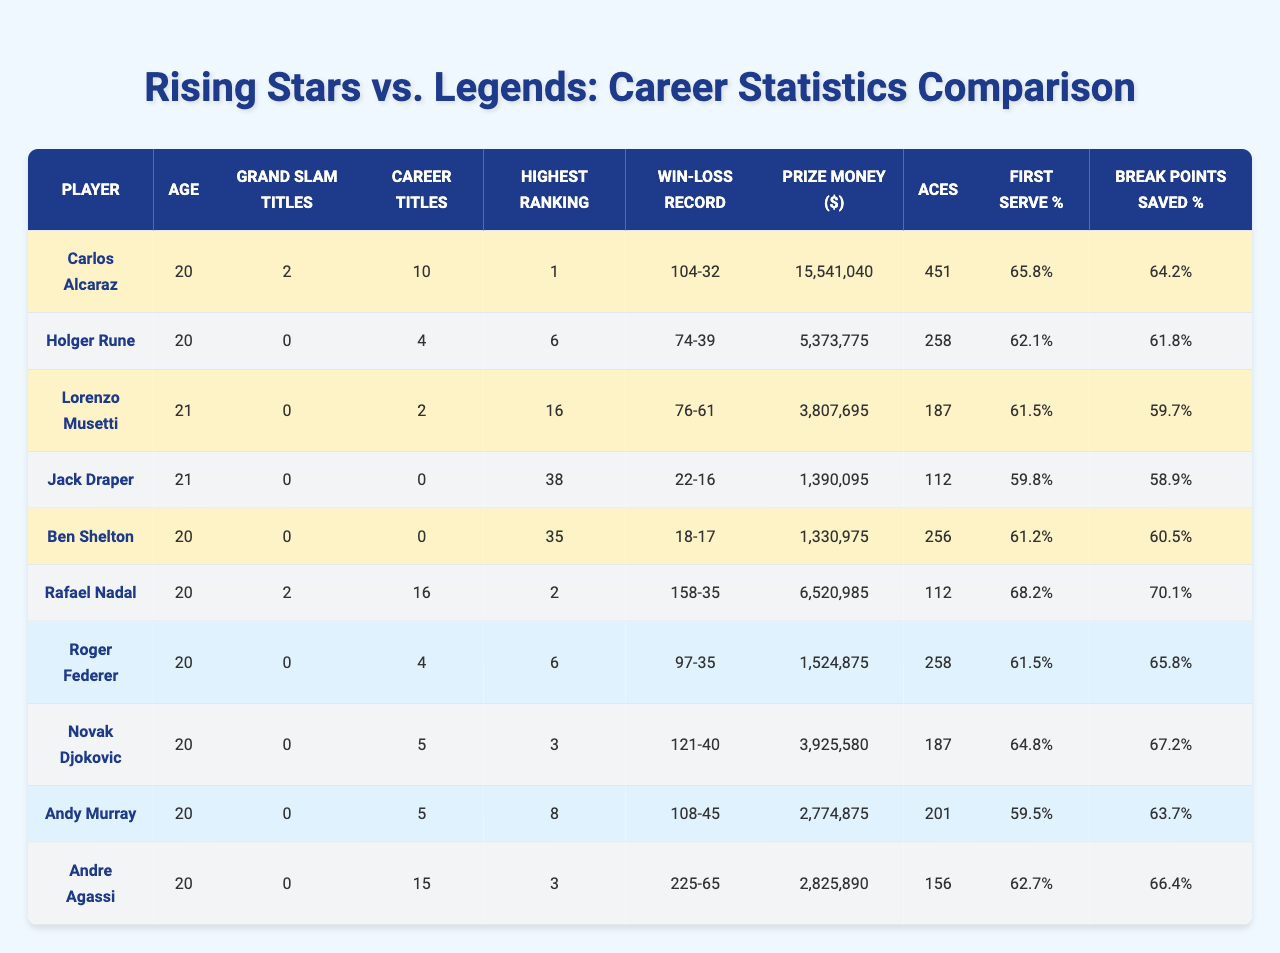What is the highest ranking achieved by Carlos Alcaraz? Referring to the table, Carlos Alcaraz has a highest ranking of 1.
Answer: 1 Who has the most career titles among the rising stars? By looking at the career titles of the rising stars, Carlos Alcaraz has 10, which is the highest among them.
Answer: 10 Does Jack Draper have any career titles? According to the table, Jack Draper has 0 career titles.
Answer: No What percentage of break points did Rafael Nadal save? The table shows that Rafael Nadal saved 70.1% of break points.
Answer: 70.1% Which player has the highest prize money among the legends? Scanning through the prize money values, Andre Agassi has the highest at $2,825,890.
Answer: $2,825,890 What is the average age of the rising stars listed in the table? The ages of the rising stars are 20, 20, 21, 21, and 20. Their total age is 102, and dividing by the 5 players gives an average age of 20.4.
Answer: 20.4 Is Holger Rune's win-loss record better than Andy Murray's? Holger Rune has a win-loss record of 74-39, which equates to a winning percentage of approximately 65.5%. Andy Murray has a record of 108-45, which results in about 70.7%. Thus, Andy's record is better.
Answer: No What is the total number of Grand Slam titles won by the legends listed? Adding up the Grand Slam titles: Rafael Nadal (2) + Roger Federer (0) + Novak Djokovic (0) + Andy Murray (0) + Andre Agassi (0) gives a total of 2.
Answer: 2 Which rising star has the lowest first serve percentage? Upon reviewing the first serve percentages, Jack Draper has the lowest at 59.8%.
Answer: 59.8% How many aces did the legends hit in total? Summing up their aces: Nadal (112) + Federer (258) + Djokovic (187) + Murray (201) + Agassi (156) gives a total of 914 aces.
Answer: 914 Who saved more break points, Lorenzo Musetti or Andre Agassi? Lorenzo Musetti saved 59.7% while Andre Agassi saved 66.4%. Since 66.4% is greater, Andre saved more.
Answer: Andre Agassi 